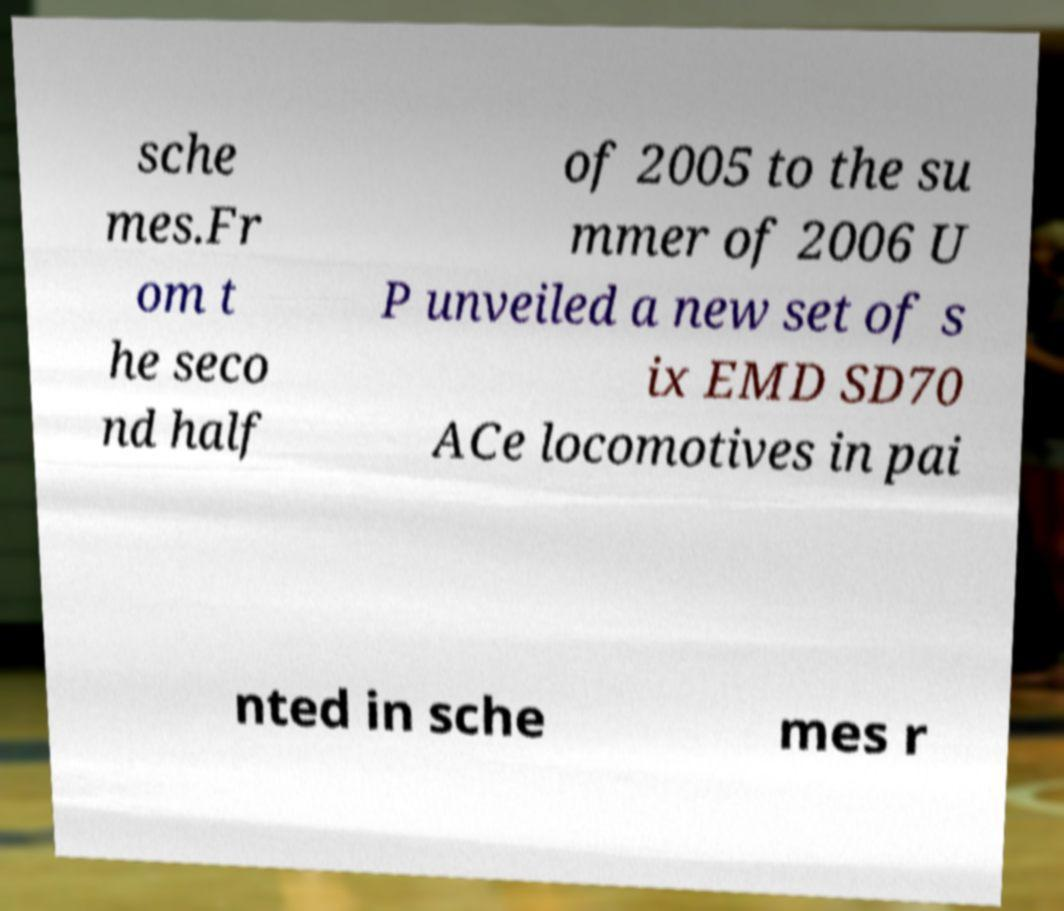Please read and relay the text visible in this image. What does it say? sche mes.Fr om t he seco nd half of 2005 to the su mmer of 2006 U P unveiled a new set of s ix EMD SD70 ACe locomotives in pai nted in sche mes r 